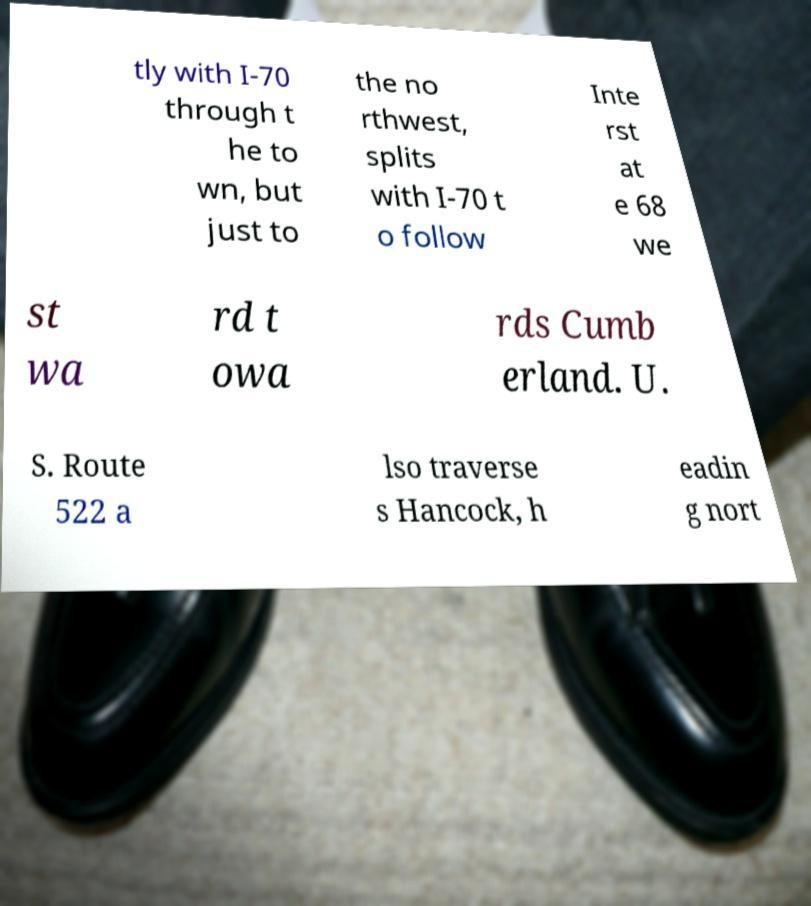What messages or text are displayed in this image? I need them in a readable, typed format. tly with I-70 through t he to wn, but just to the no rthwest, splits with I-70 t o follow Inte rst at e 68 we st wa rd t owa rds Cumb erland. U. S. Route 522 a lso traverse s Hancock, h eadin g nort 